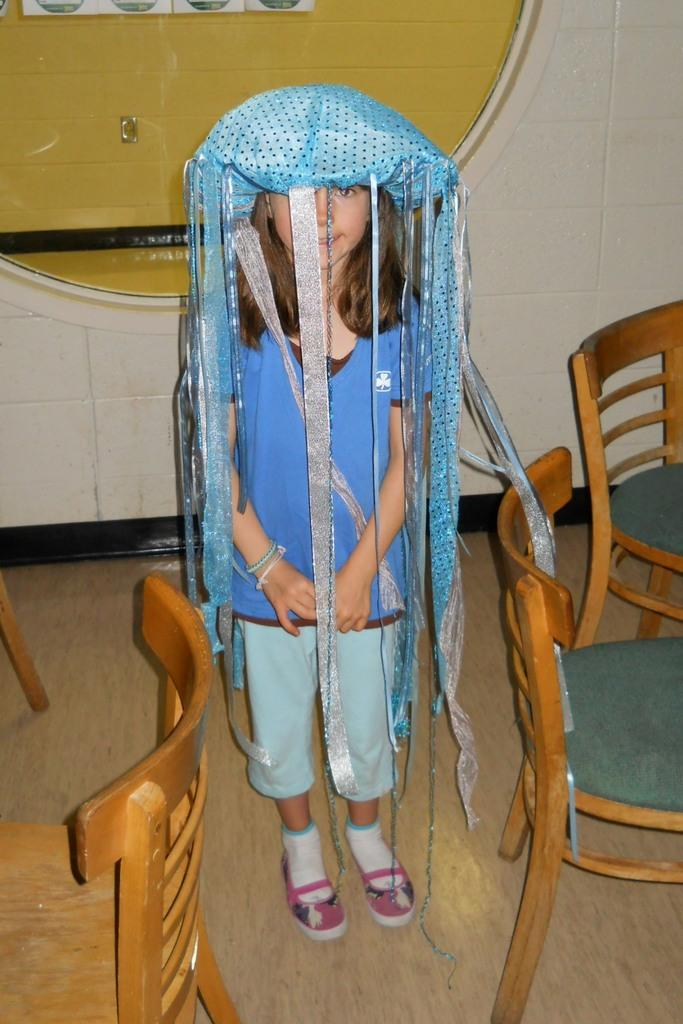Who is the main subject in the image? There is a girl in the image. What is the girl doing in the image? The girl is standing. What other objects can be seen in the image? There are chairs in the image. What is visible in the background of the image? There is a wall in the background of the image. What type of fuel is being used by the girl in the image? There is no indication in the image that the girl is using any fuel, as she is simply standing. 